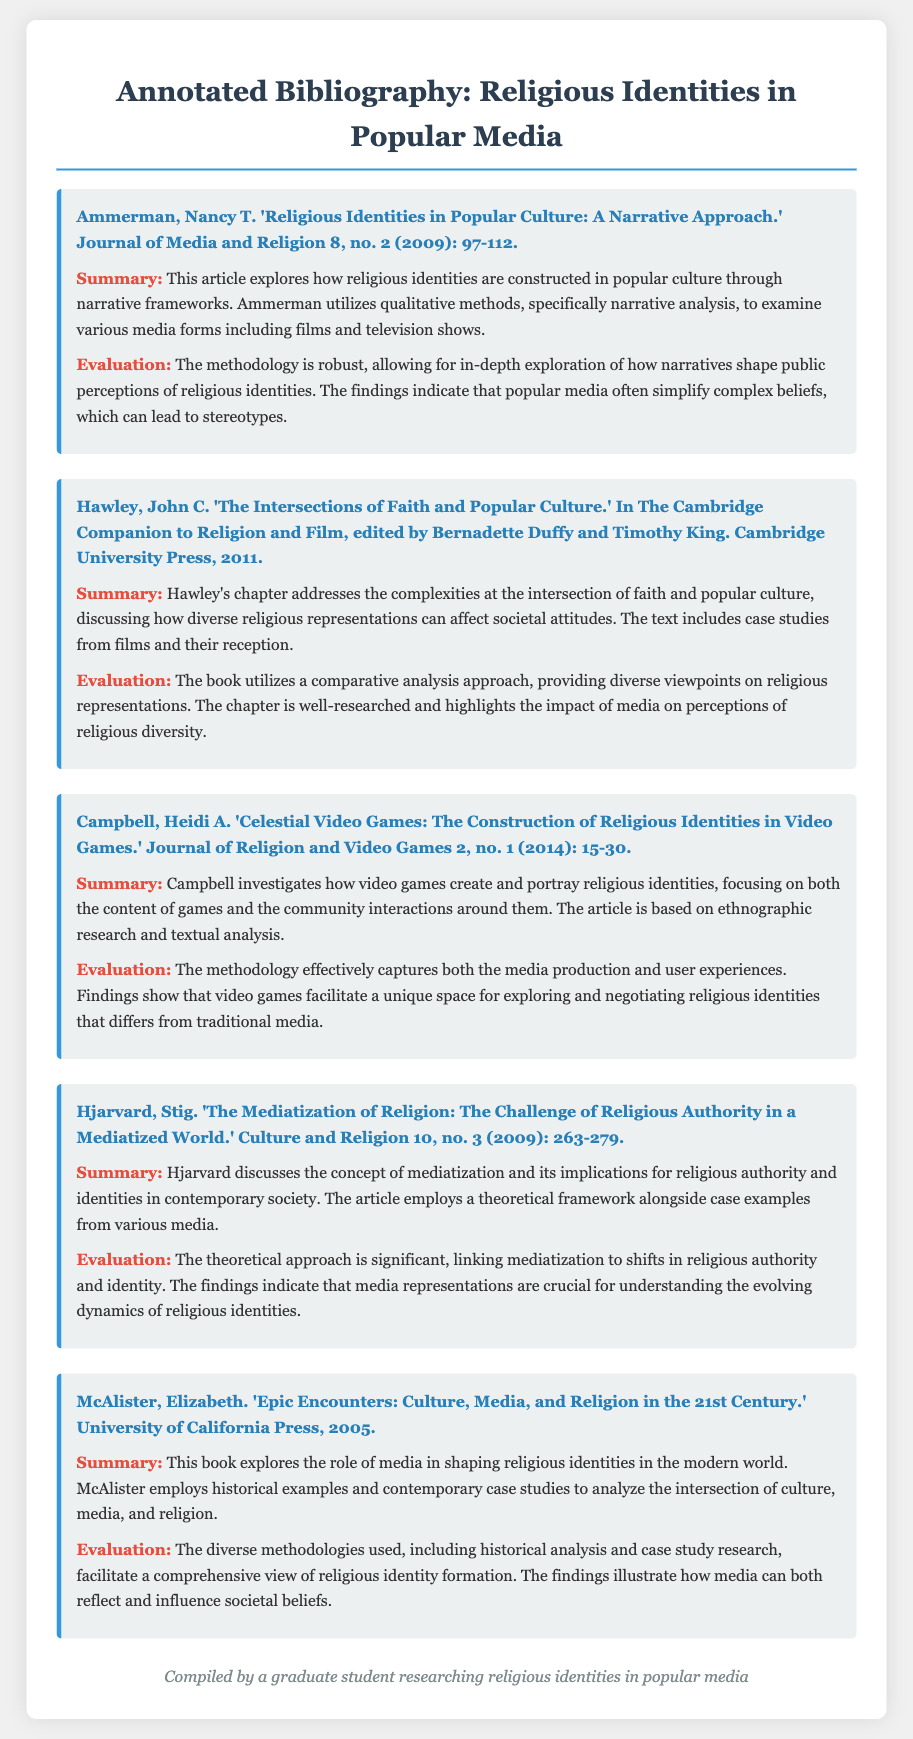What is the title of the first entry? The title of the first entry is found in the citation section of the document, which reads "Religious Identities in Popular Culture: A Narrative Approach."
Answer: Religious Identities in Popular Culture: A Narrative Approach Who is the author of the fourth entry? The author of the fourth entry can be identified from the citation, which indicates that Stig Hjarvard wrote it.
Answer: Stig Hjarvard What year was "Epic Encounters" published? The publication date for "Epic Encounters" is included in the citation, stating that it was published in 2005.
Answer: 2005 What methodology does Campbell use in her article? The methodology of Campbell's article is specified as ethnographic research and textual analysis in the summary.
Answer: Ethnographic research and textual analysis What is the main focus of Hjarvard's article? The main focus of Hjarvard's article is outlined in the summary, which discusses the concept of mediatization and its implications for religious authority and identities.
Answer: Mediatization and its implications for religious authority and identities How many entries are included in the bibliography? The number of entries can be counted from the document, which lists five distinct entries.
Answer: Five Which article examines video games? The article that examines video games is specified in the citation for "Celestial Video Games: The Construction of Religious Identities in Video Games."
Answer: Celestial Video Games: The Construction of Religious Identities in Video Games What does Ammerman's article primarily use as a methodology? Ammerman's article primarily uses narrative analysis as a methodology, as mentioned in the evaluation of her entry.
Answer: Narrative analysis 